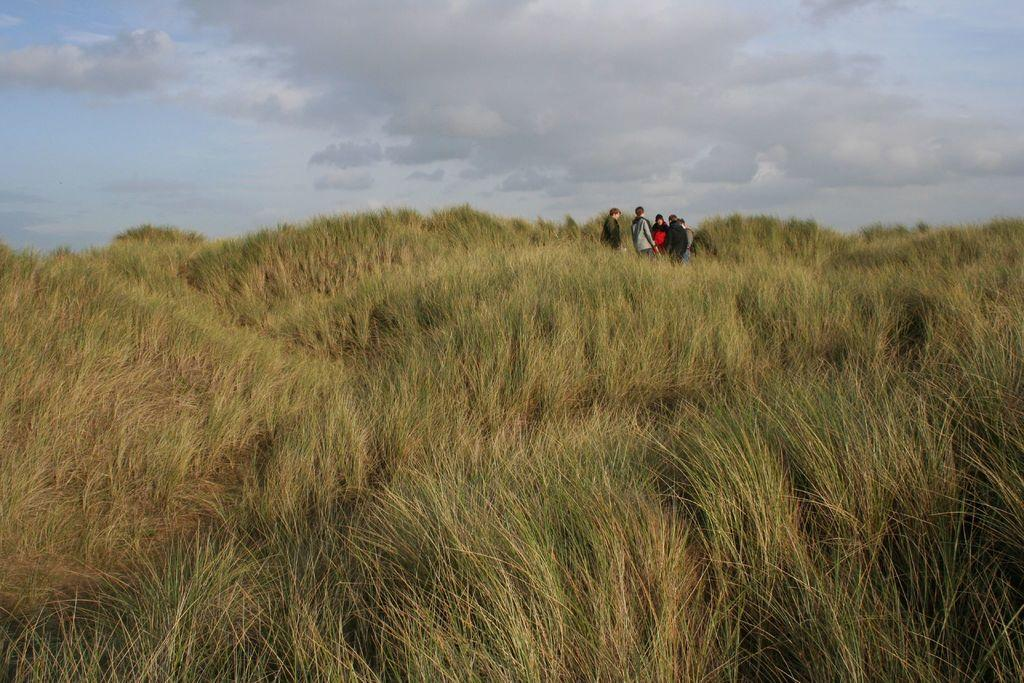What type of vegetation can be seen in the image? There is grass in the image. What are the people in the image doing? The people are standing in the grass. What is visible in the background of the image? The sky is visible in the image. Can you describe the sky in the image? The sky has some clouds in the image. What type of appliance can be seen in the hands of the people in the image? There is no appliance visible in the hands of the people in the image. 